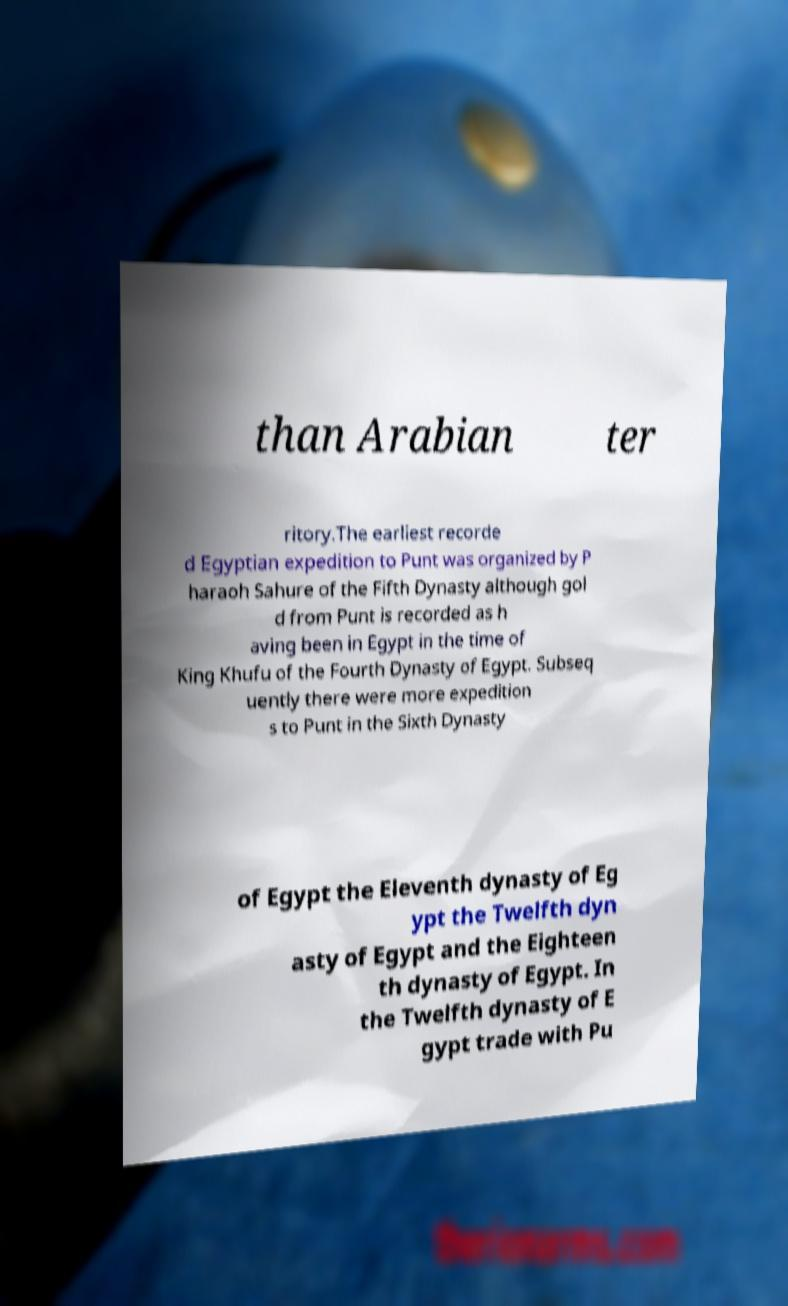Can you read and provide the text displayed in the image?This photo seems to have some interesting text. Can you extract and type it out for me? than Arabian ter ritory.The earliest recorde d Egyptian expedition to Punt was organized by P haraoh Sahure of the Fifth Dynasty although gol d from Punt is recorded as h aving been in Egypt in the time of King Khufu of the Fourth Dynasty of Egypt. Subseq uently there were more expedition s to Punt in the Sixth Dynasty of Egypt the Eleventh dynasty of Eg ypt the Twelfth dyn asty of Egypt and the Eighteen th dynasty of Egypt. In the Twelfth dynasty of E gypt trade with Pu 